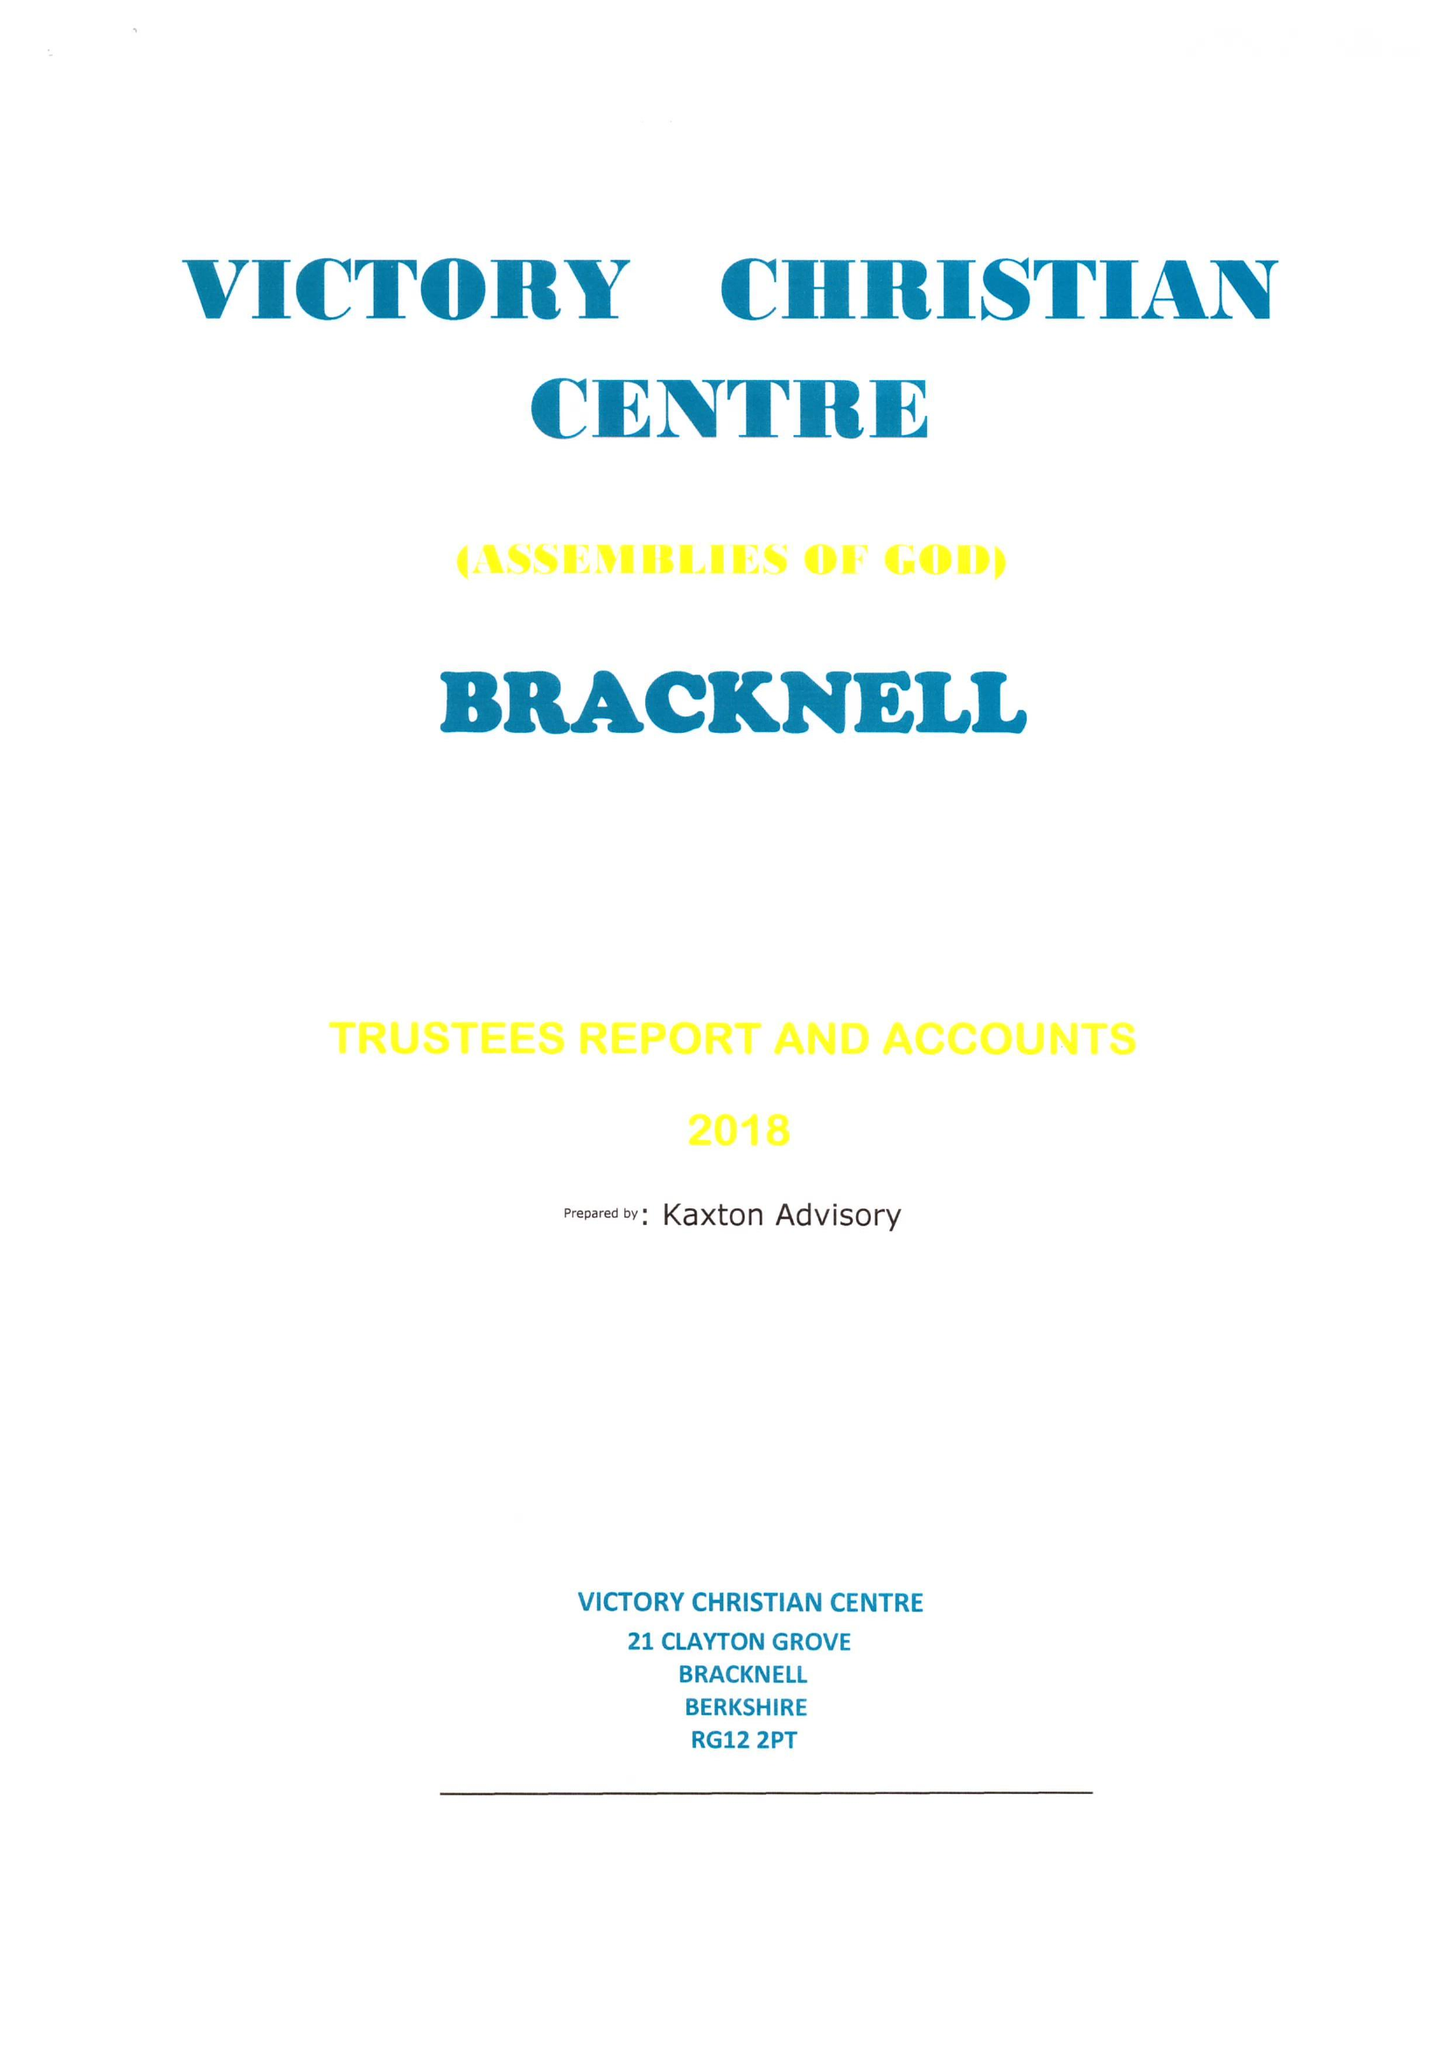What is the value for the income_annually_in_british_pounds?
Answer the question using a single word or phrase. 46531.00 